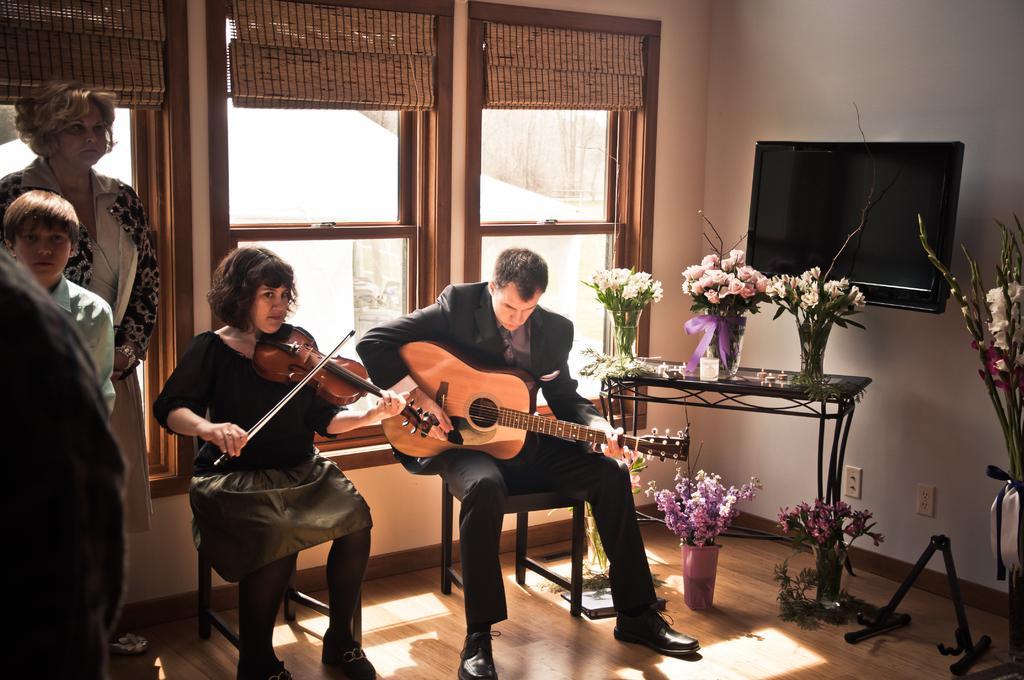Describe this image in one or two sentences. In this Picture we can see a man is sitting on the chair and playing guitar and a woman sitting beside him wearing black t- shirt and grey skirt playing violin. On the Behind of them we can see a glass window and curtain, right side we have television and wooden table in down having three flower bunch and on the left side a boy and a woman standing and listening. 